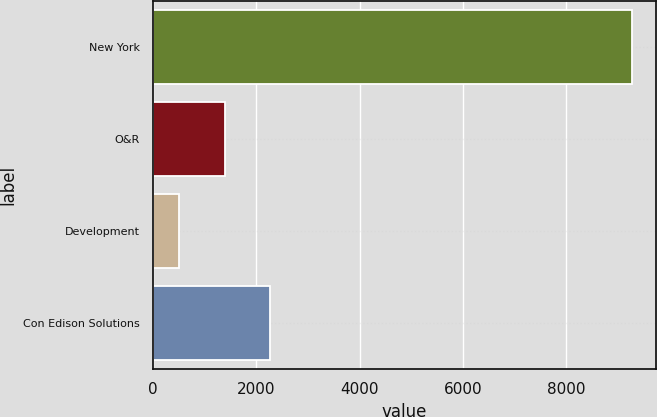Convert chart. <chart><loc_0><loc_0><loc_500><loc_500><bar_chart><fcel>New York<fcel>O&R<fcel>Development<fcel>Con Edison Solutions<nl><fcel>9272<fcel>1388<fcel>512<fcel>2264<nl></chart> 